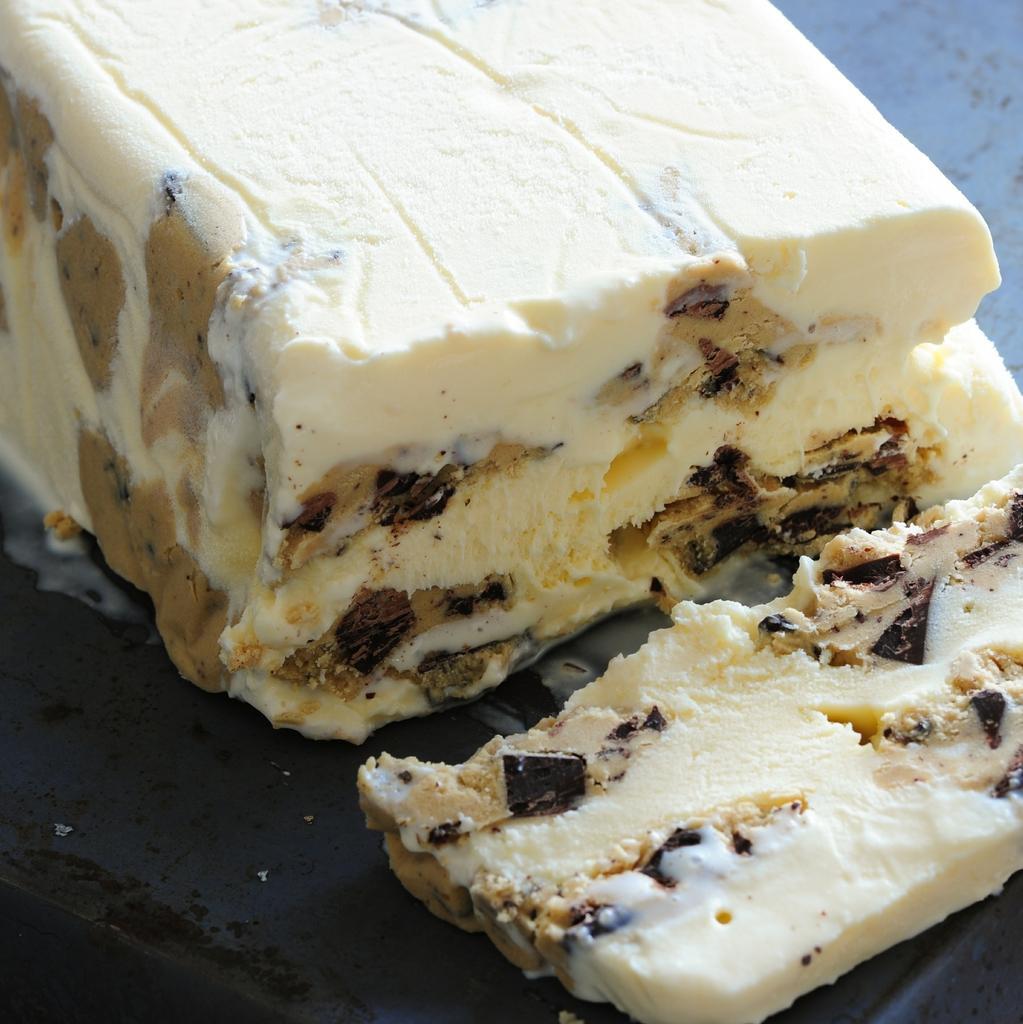Could you give a brief overview of what you see in this image? In this picture we can see an ice-cream on the surface.  